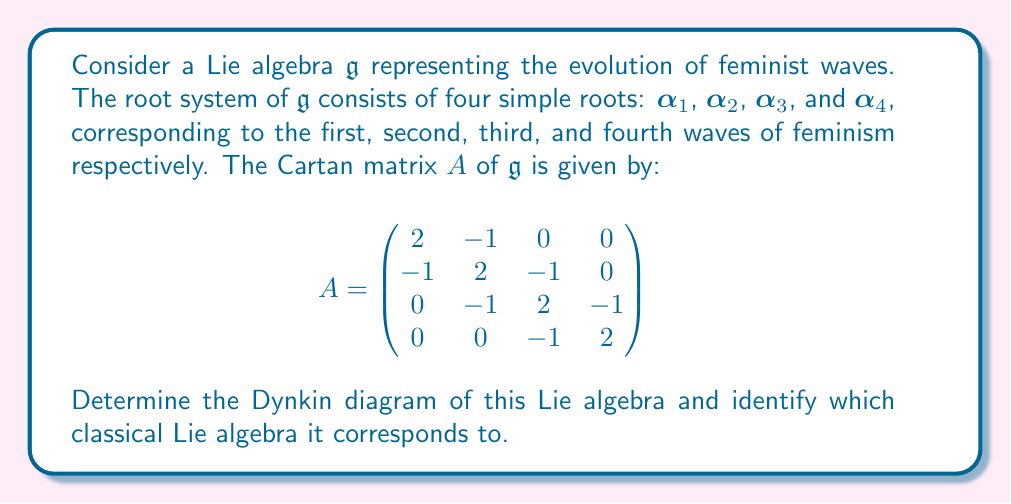Show me your answer to this math problem. To solve this problem, we need to follow these steps:

1) First, let's interpret the Cartan matrix. Each row (or column) corresponds to a simple root, and the entries $a_{ij}$ represent the relationship between roots $\alpha_i$ and $\alpha_j$.

2) In a Dynkin diagram, each node represents a simple root. The number of edges between nodes $i$ and $j$ is determined by the product $a_{ij}a_{ji}$:
   - If $a_{ij}a_{ji} = 0$, there's no edge.
   - If $a_{ij}a_{ji} = 1$, there's a single edge.
   - If $a_{ij}a_{ji} = 2$, there's a double edge.
   - If $a_{ij}a_{ji} = 3$, there's a triple edge.

3) Looking at our Cartan matrix:
   - $a_{12}a_{21} = a_{23}a_{32} = a_{34}a_{43} = 1$, so there are single edges between nodes 1-2, 2-3, and 3-4.
   - All other off-diagonal products are 0, so there are no other edges.

4) The Dynkin diagram would look like this:

[asy]
unitsize(1cm);
for(int i=0; i<4; ++i) {
  dot((i,0));
  if(i<3) draw((i,0)--(i+1,0));
}
label("$\alpha_1$", (0,-0.5));
label("$\alpha_2$", (1,-0.5));
label("$\alpha_3$", (2,-0.5));
label("$\alpha_4$", (3,-0.5));
[/asy]

5) This Dynkin diagram corresponds to the Lie algebra $A_4$, which is isomorphic to $\mathfrak{sl}(5,\mathbb{C})$.

In the context of feminist waves, this structure suggests that each wave (represented by a simple root) is directly influenced by the wave immediately preceding it, forming a chain of progressive development in feminist thought and action.
Answer: The Dynkin diagram is a linear chain of four nodes connected by single edges, corresponding to the Lie algebra $A_4 \cong \mathfrak{sl}(5,\mathbb{C})$. 